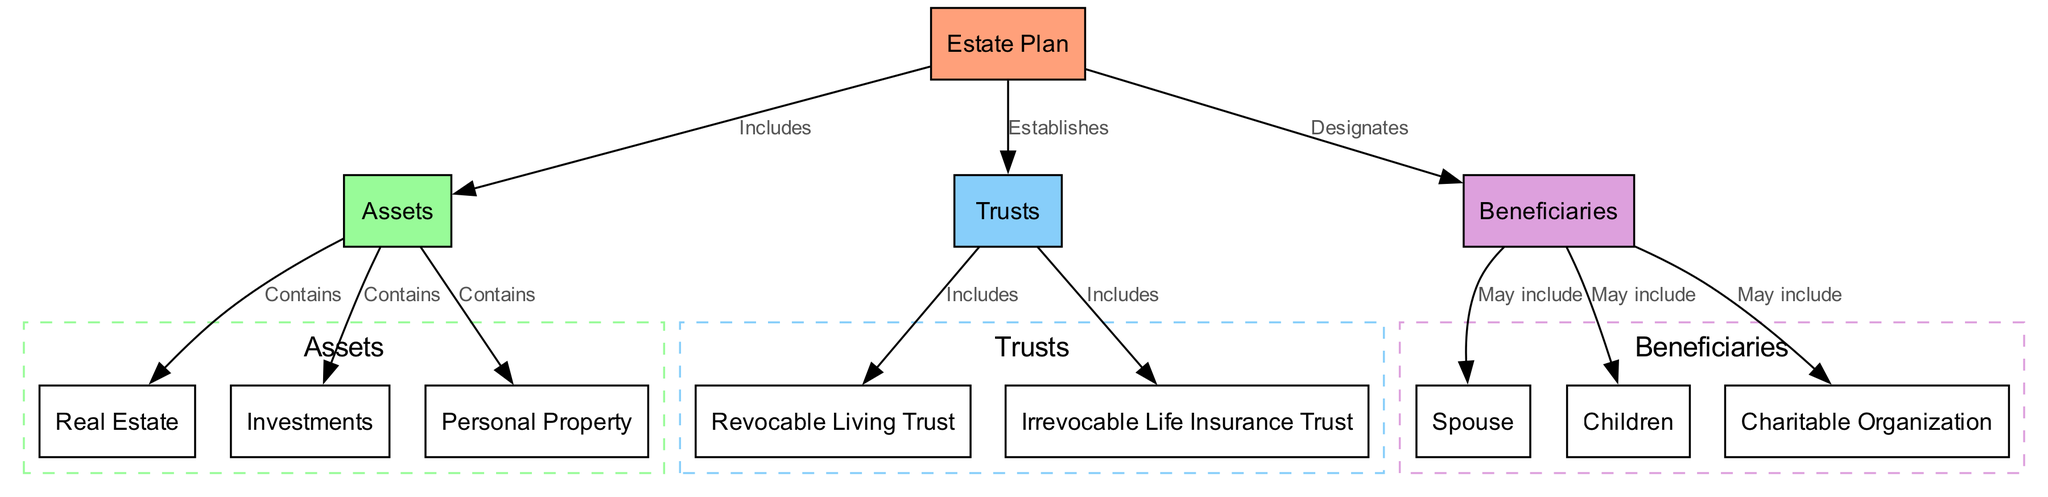What are the primary components of the estate plan? The estate plan includes assets, trusts, and beneficiaries, as indicated by the edges connecting from the estate plan node to each of these three nodes.
Answer: Assets, Trusts, Beneficiaries How many assets categories are represented in the diagram? The diagram shows three categories under assets: real estate, investments, and personal property, verified by counting the edges leading from the assets node.
Answer: 3 What type of trust is included under the trusts category? The diagram indicates two types of trusts: revocable living trust and irrevocable life insurance trust, which can be identified under the edges connected to the trusts node.
Answer: Revocable Living Trust, Irrevocable Life Insurance Trust Who can be designated as beneficiaries in the estate plan? The beneficiaries may include a spouse, children, and a charitable organization, as shown by the edges leading from the beneficiaries node to these entities.
Answer: Spouse, Children, Charitable Organization What connection is present between the estate plan and trusts? The edge labeled "Establishes" indicates a direct connection from the estate plan node to the trusts node, showing that the estate plan is responsible for establishing the trusts.
Answer: Establishes How many beneficiaries can be included as per the diagram? The diagram presents three potential beneficiaries - spouse, children, and charity - all of which are explicitly linked to the beneficiaries node.
Answer: 3 Which subset of the estate plan deals with asset types? The assets subset encapsulates real estate, investments, and personal property, which are all connected to the overall assets node in the diagram.
Answer: Assets What is the relationship between trusts and the revocable living trust? The edge labeled "Includes" indicates that the revocable living trust is a component of the trusts category, which establishes its relationship to the overall trust structure.
Answer: Includes Which category do real estate, investments, and personal property belong to? All three categories belong to the assets, as they are grouped under the assets node with edges that denote a 'Contains' relationship.
Answer: Assets 